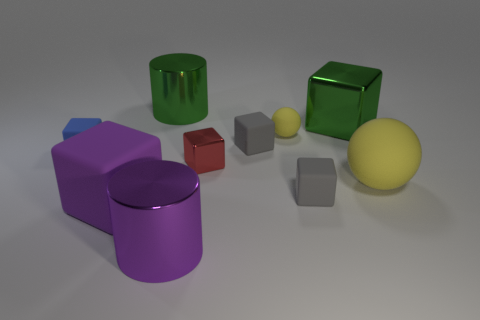Subtract all large purple rubber cubes. How many cubes are left? 5 Subtract all brown balls. How many gray blocks are left? 2 Subtract all blue blocks. How many blocks are left? 5 Subtract 1 blocks. How many blocks are left? 5 Subtract all yellow cubes. Subtract all brown spheres. How many cubes are left? 6 Subtract all cylinders. How many objects are left? 8 Subtract all small red blocks. Subtract all yellow matte objects. How many objects are left? 7 Add 1 blue objects. How many blue objects are left? 2 Add 8 big purple matte objects. How many big purple matte objects exist? 9 Subtract 0 gray spheres. How many objects are left? 10 